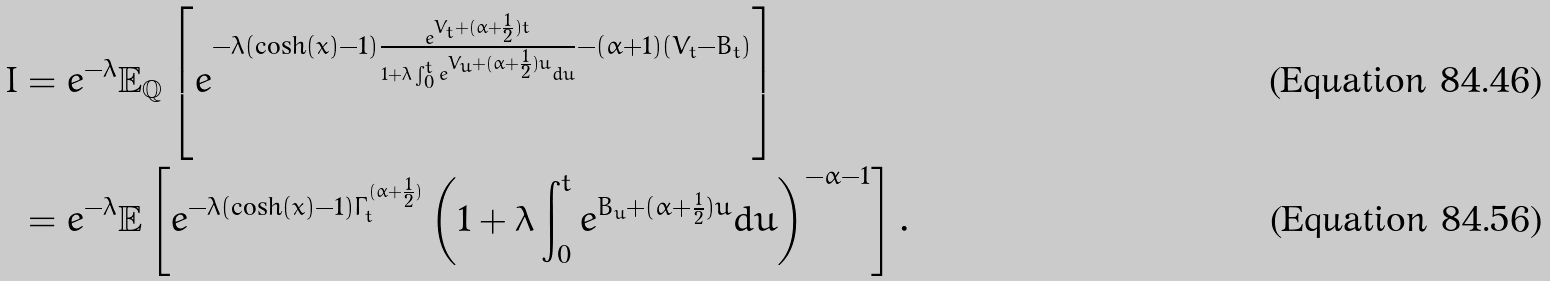<formula> <loc_0><loc_0><loc_500><loc_500>I & = e ^ { - \lambda } \mathbb { E } _ { \mathbb { Q } } \left [ e ^ { - \lambda ( \cosh ( x ) - 1 ) \frac { e ^ { V _ { t } + ( \alpha + \frac { 1 } { 2 } ) t } } { 1 + \lambda \int _ { 0 } ^ { t } e ^ { V _ { u } + ( \alpha + \frac { 1 } { 2 } ) u } d u } - ( \alpha + 1 ) ( V _ { t } - B _ { t } ) } \right ] \\ & = e ^ { - \lambda } \mathbb { E } \left [ e ^ { - \lambda ( \cosh ( x ) - 1 ) \Gamma _ { t } ^ { ( \alpha + \frac { 1 } { 2 } ) } } \left ( 1 + \lambda \int _ { 0 } ^ { t } e ^ { B _ { u } + ( \alpha + \frac { 1 } { 2 } ) u } d u \right ) ^ { - \alpha - 1 } \right ] .</formula> 